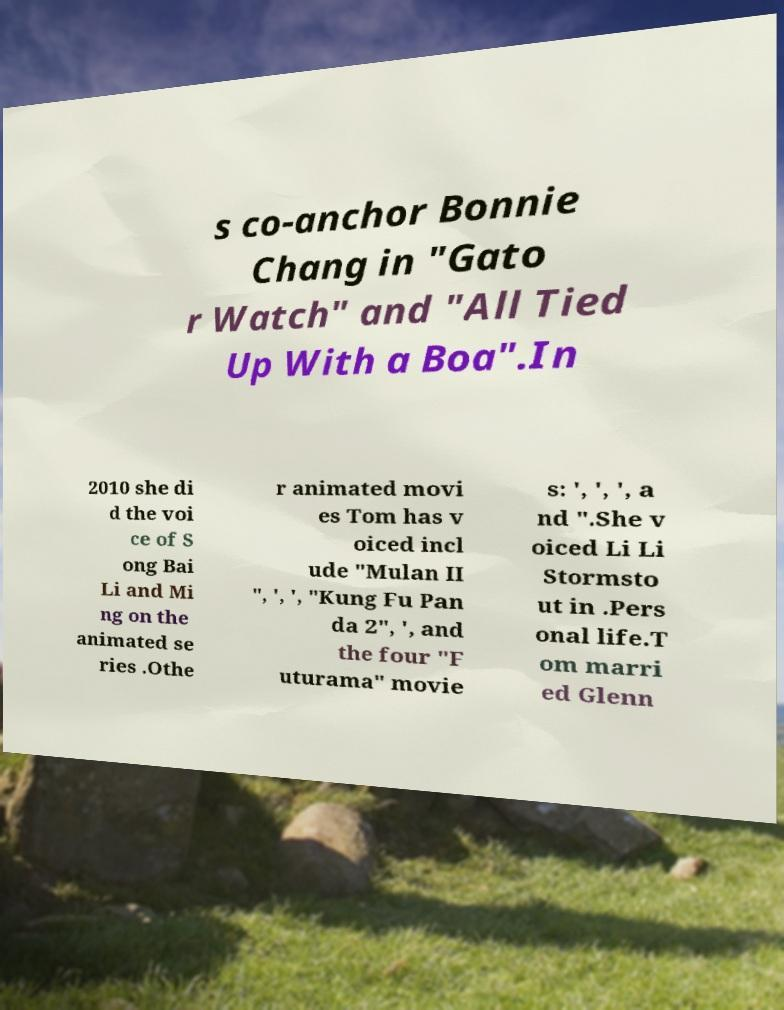Please read and relay the text visible in this image. What does it say? s co-anchor Bonnie Chang in "Gato r Watch" and "All Tied Up With a Boa".In 2010 she di d the voi ce of S ong Bai Li and Mi ng on the animated se ries .Othe r animated movi es Tom has v oiced incl ude "Mulan II ", ', ', "Kung Fu Pan da 2", ', and the four "F uturama" movie s: ', ', ', a nd ".She v oiced Li Li Stormsto ut in .Pers onal life.T om marri ed Glenn 